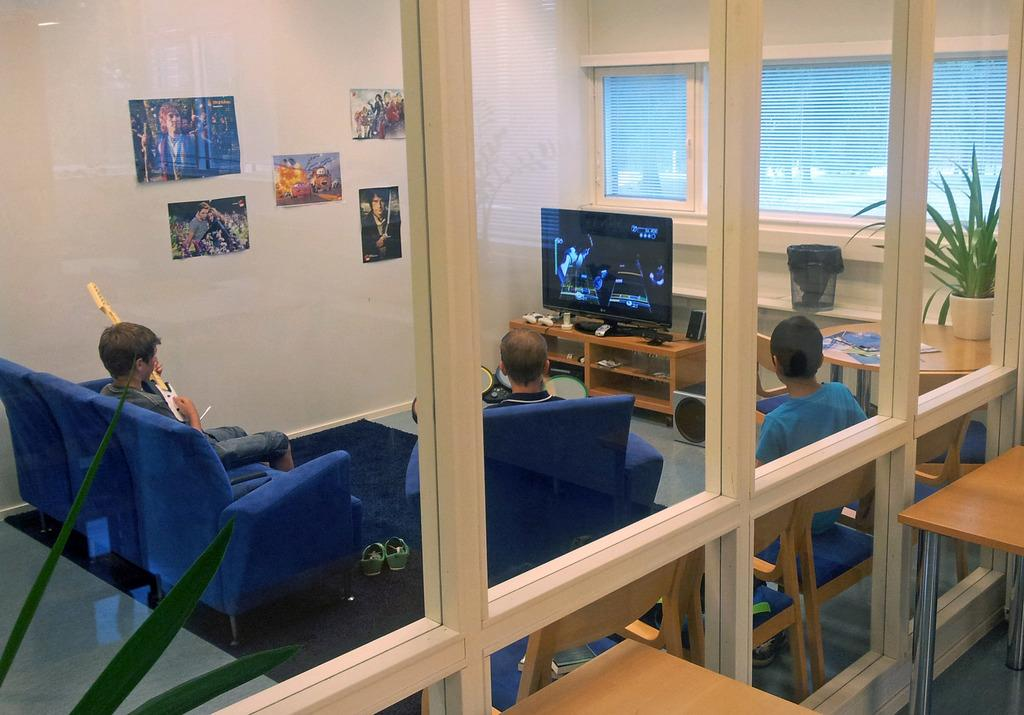What material is the window in the image made of? The window in the image is made of wood. How many people are sitting on chairs in the image? There are three persons sitting on chairs in the image. What are the persons doing while sitting on the chairs? The persons are watching a television. What is one person doing in addition to watching television? One person on the left side is playing a guitar. What color is the orange hanging from the wing in the image? There is no orange or wing present in the image. Is the scarf being used by any of the persons in the image? There is no scarf visible in the image. 